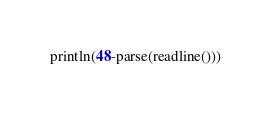Convert code to text. <code><loc_0><loc_0><loc_500><loc_500><_Julia_>println(48-parse(readline()))</code> 